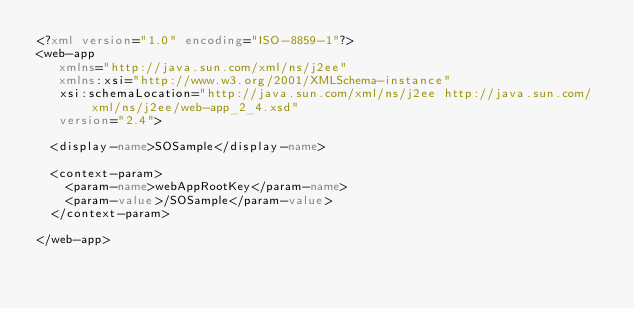<code> <loc_0><loc_0><loc_500><loc_500><_XML_><?xml version="1.0" encoding="ISO-8859-1"?>
<web-app 
   xmlns="http://java.sun.com/xml/ns/j2ee" 
   xmlns:xsi="http://www.w3.org/2001/XMLSchema-instance"
   xsi:schemaLocation="http://java.sun.com/xml/ns/j2ee http://java.sun.com/xml/ns/j2ee/web-app_2_4.xsd" 
   version="2.4"> 

	<display-name>SOSample</display-name>
	
	<context-param>
		<param-name>webAppRootKey</param-name>
		<param-value>/SOSample</param-value>
	</context-param>

</web-app>
</code> 